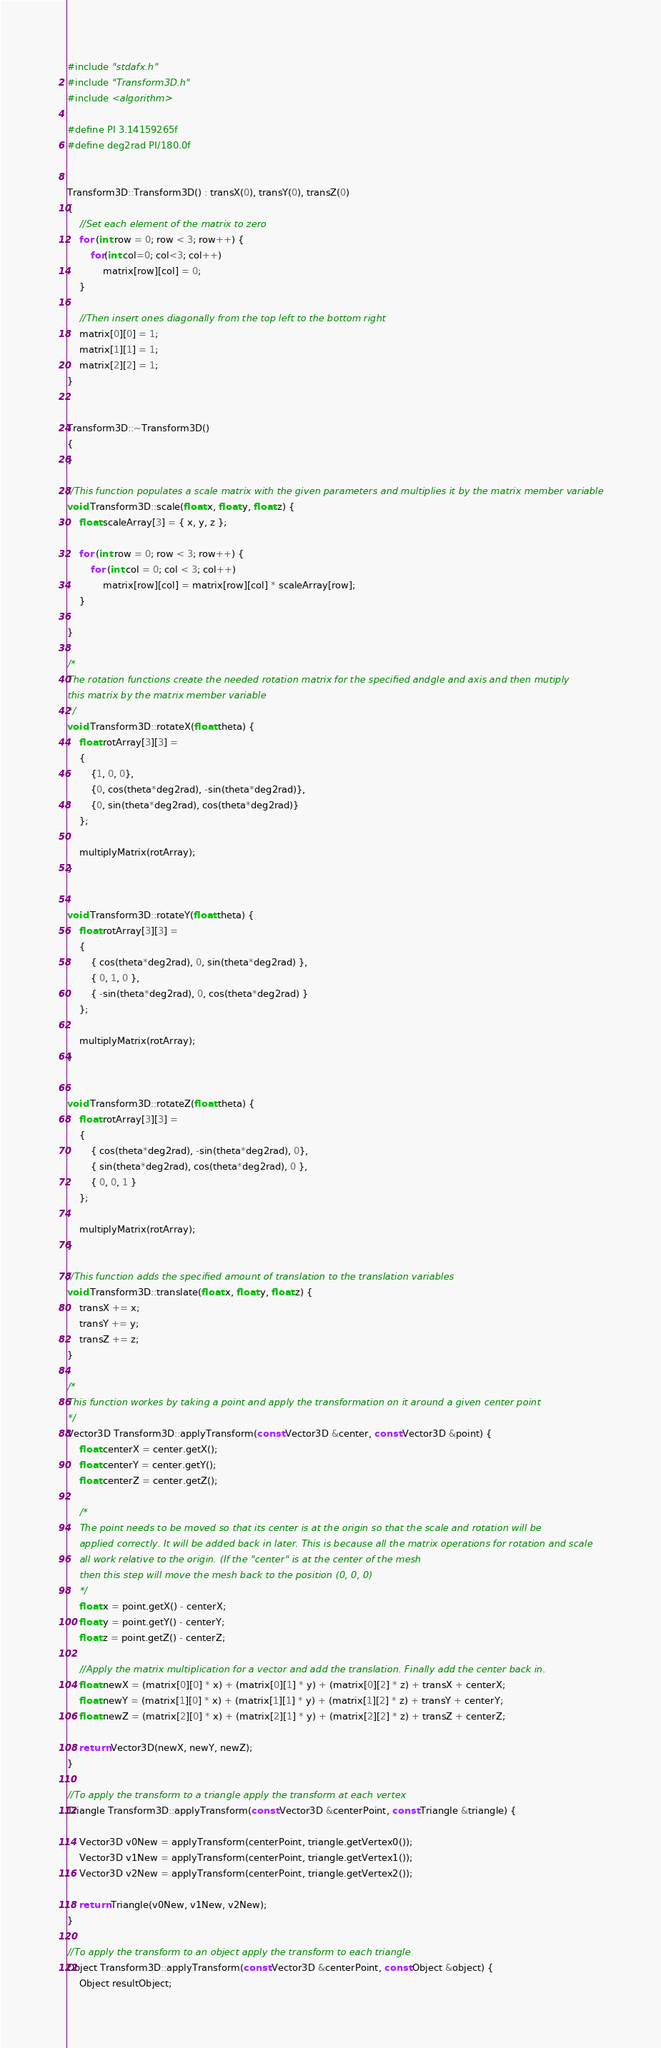<code> <loc_0><loc_0><loc_500><loc_500><_C++_>#include "stdafx.h"
#include "Transform3D.h"
#include <algorithm> 

#define PI 3.14159265f
#define deg2rad PI/180.0f


Transform3D::Transform3D() : transX(0), transY(0), transZ(0)
{
	//Set each element of the matrix to zero
	for (int row = 0; row < 3; row++) {
		for(int col=0; col<3; col++)
			matrix[row][col] = 0;
	}
	
	//Then insert ones diagonally from the top left to the bottom right
	matrix[0][0] = 1;
	matrix[1][1] = 1;
	matrix[2][2] = 1;
}


Transform3D::~Transform3D()
{
}

//This function populates a scale matrix with the given parameters and multiplies it by the matrix member variable
void Transform3D::scale(float x, float y, float z) {
	float scaleArray[3] = { x, y, z };

	for (int row = 0; row < 3; row++) {
		for (int col = 0; col < 3; col++)
			matrix[row][col] = matrix[row][col] * scaleArray[row];
	}

}

/*
The rotation functions create the needed rotation matrix for the specified andgle and axis and then mutiply 
this matrix by the matrix member variable
*/
void Transform3D::rotateX(float theta) {
	float rotArray[3][3] = 
	{
		{1, 0, 0}, 
		{0, cos(theta*deg2rad), -sin(theta*deg2rad)}, 
		{0, sin(theta*deg2rad), cos(theta*deg2rad)}
	};

	multiplyMatrix(rotArray);
}


void Transform3D::rotateY(float theta) {
	float rotArray[3][3] =
	{
		{ cos(theta*deg2rad), 0, sin(theta*deg2rad) },
		{ 0, 1, 0 },
		{ -sin(theta*deg2rad), 0, cos(theta*deg2rad) }
	};

	multiplyMatrix(rotArray);
}


void Transform3D::rotateZ(float theta) {
	float rotArray[3][3] =
	{
		{ cos(theta*deg2rad), -sin(theta*deg2rad), 0},
		{ sin(theta*deg2rad), cos(theta*deg2rad), 0 },
		{ 0, 0, 1 }
	};

	multiplyMatrix(rotArray);
}

//This function adds the specified amount of translation to the translation variables 
void Transform3D::translate(float x, float y, float z) {
	transX += x;
	transY += y;
	transZ += z;
}

/*
This function workes by taking a point and apply the transformation on it around a given center point
*/
Vector3D Transform3D::applyTransform(const Vector3D &center, const Vector3D &point) {
	float centerX = center.getX();
	float centerY = center.getY();
	float centerZ = center.getZ();

	/*
	The point needs to be moved so that its center is at the origin so that the scale and rotation will be
	applied correctly. It will be added back in later. This is because all the matrix operations for rotation and scale
	all work relative to the origin. (If the "center" is at the center of the mesh
	then this step will move the mesh back to the position (0, 0, 0)
	*/
	float x = point.getX() - centerX;
	float y = point.getY() - centerY;
	float z = point.getZ() - centerZ;

	//Apply the matrix multiplication for a vector and add the translation. Finally add the center back in. 
	float newX = (matrix[0][0] * x) + (matrix[0][1] * y) + (matrix[0][2] * z) + transX + centerX;
	float newY = (matrix[1][0] * x) + (matrix[1][1] * y) + (matrix[1][2] * z) + transY + centerY;
	float newZ = (matrix[2][0] * x) + (matrix[2][1] * y) + (matrix[2][2] * z) + transZ + centerZ;

	return Vector3D(newX, newY, newZ);
}

//To apply the transform to a triangle apply the transform at each vertex
Triangle Transform3D::applyTransform(const Vector3D &centerPoint, const Triangle &triangle) {

	Vector3D v0New = applyTransform(centerPoint, triangle.getVertex0());
	Vector3D v1New = applyTransform(centerPoint, triangle.getVertex1());
	Vector3D v2New = applyTransform(centerPoint, triangle.getVertex2());

	return Triangle(v0New, v1New, v2New);
}

//To apply the transform to an object apply the transform to each triangle
Object Transform3D::applyTransform(const Vector3D &centerPoint, const Object &object) {
	Object resultObject;</code> 